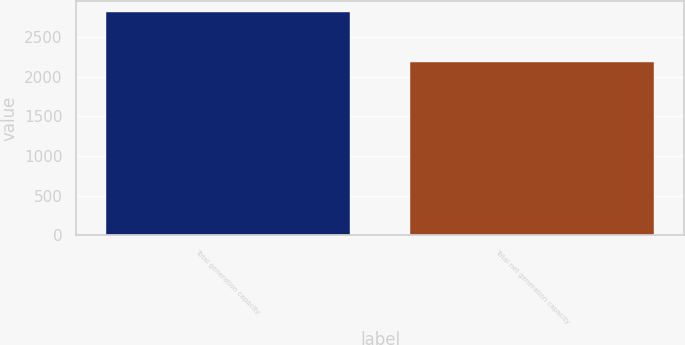Convert chart to OTSL. <chart><loc_0><loc_0><loc_500><loc_500><bar_chart><fcel>Total generation capacity<fcel>Total net generation capacity<nl><fcel>2808<fcel>2178<nl></chart> 